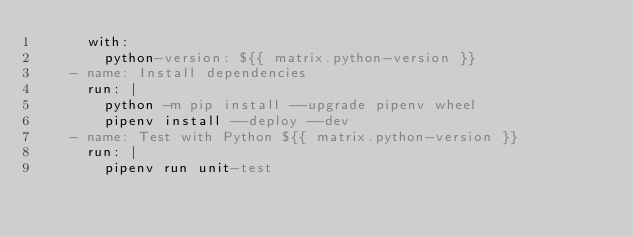<code> <loc_0><loc_0><loc_500><loc_500><_YAML_>      with:
        python-version: ${{ matrix.python-version }}
    - name: Install dependencies
      run: |
        python -m pip install --upgrade pipenv wheel
        pipenv install --deploy --dev
    - name: Test with Python ${{ matrix.python-version }}
      run: |
        pipenv run unit-test</code> 